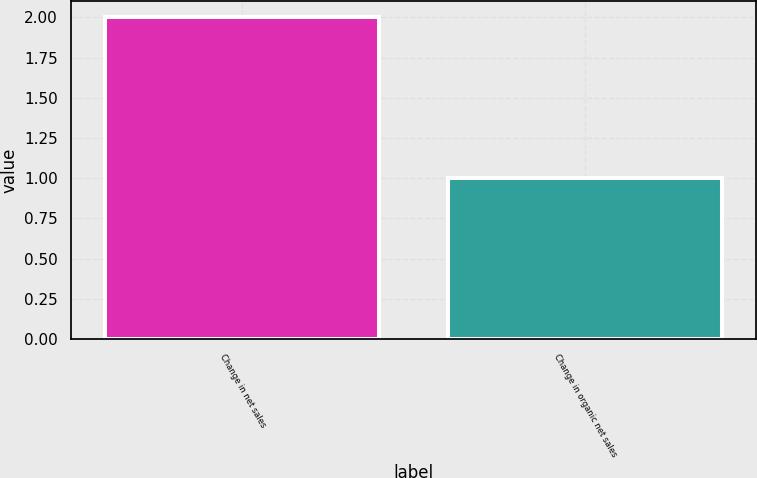Convert chart to OTSL. <chart><loc_0><loc_0><loc_500><loc_500><bar_chart><fcel>Change in net sales<fcel>Change in organic net sales<nl><fcel>2<fcel>1<nl></chart> 